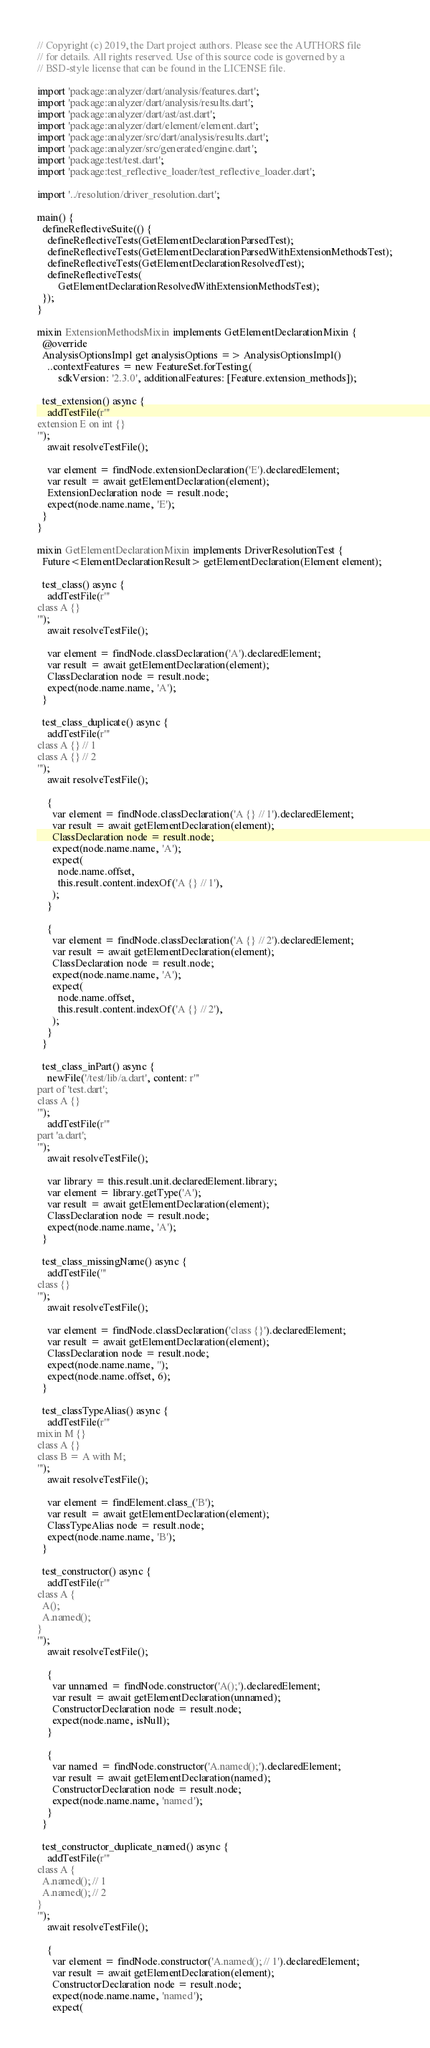<code> <loc_0><loc_0><loc_500><loc_500><_Dart_>// Copyright (c) 2019, the Dart project authors. Please see the AUTHORS file
// for details. All rights reserved. Use of this source code is governed by a
// BSD-style license that can be found in the LICENSE file.

import 'package:analyzer/dart/analysis/features.dart';
import 'package:analyzer/dart/analysis/results.dart';
import 'package:analyzer/dart/ast/ast.dart';
import 'package:analyzer/dart/element/element.dart';
import 'package:analyzer/src/dart/analysis/results.dart';
import 'package:analyzer/src/generated/engine.dart';
import 'package:test/test.dart';
import 'package:test_reflective_loader/test_reflective_loader.dart';

import '../resolution/driver_resolution.dart';

main() {
  defineReflectiveSuite(() {
    defineReflectiveTests(GetElementDeclarationParsedTest);
    defineReflectiveTests(GetElementDeclarationParsedWithExtensionMethodsTest);
    defineReflectiveTests(GetElementDeclarationResolvedTest);
    defineReflectiveTests(
        GetElementDeclarationResolvedWithExtensionMethodsTest);
  });
}

mixin ExtensionMethodsMixin implements GetElementDeclarationMixin {
  @override
  AnalysisOptionsImpl get analysisOptions => AnalysisOptionsImpl()
    ..contextFeatures = new FeatureSet.forTesting(
        sdkVersion: '2.3.0', additionalFeatures: [Feature.extension_methods]);

  test_extension() async {
    addTestFile(r'''
extension E on int {}
''');
    await resolveTestFile();

    var element = findNode.extensionDeclaration('E').declaredElement;
    var result = await getElementDeclaration(element);
    ExtensionDeclaration node = result.node;
    expect(node.name.name, 'E');
  }
}

mixin GetElementDeclarationMixin implements DriverResolutionTest {
  Future<ElementDeclarationResult> getElementDeclaration(Element element);

  test_class() async {
    addTestFile(r'''
class A {}
''');
    await resolveTestFile();

    var element = findNode.classDeclaration('A').declaredElement;
    var result = await getElementDeclaration(element);
    ClassDeclaration node = result.node;
    expect(node.name.name, 'A');
  }

  test_class_duplicate() async {
    addTestFile(r'''
class A {} // 1
class A {} // 2
''');
    await resolveTestFile();

    {
      var element = findNode.classDeclaration('A {} // 1').declaredElement;
      var result = await getElementDeclaration(element);
      ClassDeclaration node = result.node;
      expect(node.name.name, 'A');
      expect(
        node.name.offset,
        this.result.content.indexOf('A {} // 1'),
      );
    }

    {
      var element = findNode.classDeclaration('A {} // 2').declaredElement;
      var result = await getElementDeclaration(element);
      ClassDeclaration node = result.node;
      expect(node.name.name, 'A');
      expect(
        node.name.offset,
        this.result.content.indexOf('A {} // 2'),
      );
    }
  }

  test_class_inPart() async {
    newFile('/test/lib/a.dart', content: r'''
part of 'test.dart';
class A {}
''');
    addTestFile(r'''
part 'a.dart';
''');
    await resolveTestFile();

    var library = this.result.unit.declaredElement.library;
    var element = library.getType('A');
    var result = await getElementDeclaration(element);
    ClassDeclaration node = result.node;
    expect(node.name.name, 'A');
  }

  test_class_missingName() async {
    addTestFile('''
class {}
''');
    await resolveTestFile();

    var element = findNode.classDeclaration('class {}').declaredElement;
    var result = await getElementDeclaration(element);
    ClassDeclaration node = result.node;
    expect(node.name.name, '');
    expect(node.name.offset, 6);
  }

  test_classTypeAlias() async {
    addTestFile(r'''
mixin M {}
class A {}
class B = A with M;
''');
    await resolveTestFile();

    var element = findElement.class_('B');
    var result = await getElementDeclaration(element);
    ClassTypeAlias node = result.node;
    expect(node.name.name, 'B');
  }

  test_constructor() async {
    addTestFile(r'''
class A {
  A();
  A.named();
}
''');
    await resolveTestFile();

    {
      var unnamed = findNode.constructor('A();').declaredElement;
      var result = await getElementDeclaration(unnamed);
      ConstructorDeclaration node = result.node;
      expect(node.name, isNull);
    }

    {
      var named = findNode.constructor('A.named();').declaredElement;
      var result = await getElementDeclaration(named);
      ConstructorDeclaration node = result.node;
      expect(node.name.name, 'named');
    }
  }

  test_constructor_duplicate_named() async {
    addTestFile(r'''
class A {
  A.named(); // 1
  A.named(); // 2
}
''');
    await resolveTestFile();

    {
      var element = findNode.constructor('A.named(); // 1').declaredElement;
      var result = await getElementDeclaration(element);
      ConstructorDeclaration node = result.node;
      expect(node.name.name, 'named');
      expect(</code> 